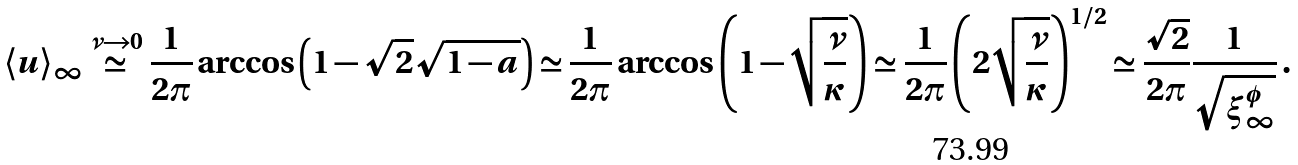<formula> <loc_0><loc_0><loc_500><loc_500>\langle u \rangle _ { \infty } \stackrel { \nu \rightarrow 0 } { \simeq } \frac { 1 } { 2 \pi } \arccos \left ( 1 - \sqrt { 2 } \sqrt { 1 - a } \right ) \simeq \frac { 1 } { 2 \pi } \arccos \left ( 1 - \sqrt { \frac { \nu } { \kappa } } \right ) \simeq \frac { 1 } { 2 \pi } \left ( 2 \sqrt { \frac { \nu } { \kappa } } \right ) ^ { 1 / 2 } \simeq \frac { \sqrt { 2 } } { 2 \pi } \frac { 1 } { \sqrt { \xi ^ { \phi } _ { \infty } } } \, .</formula> 